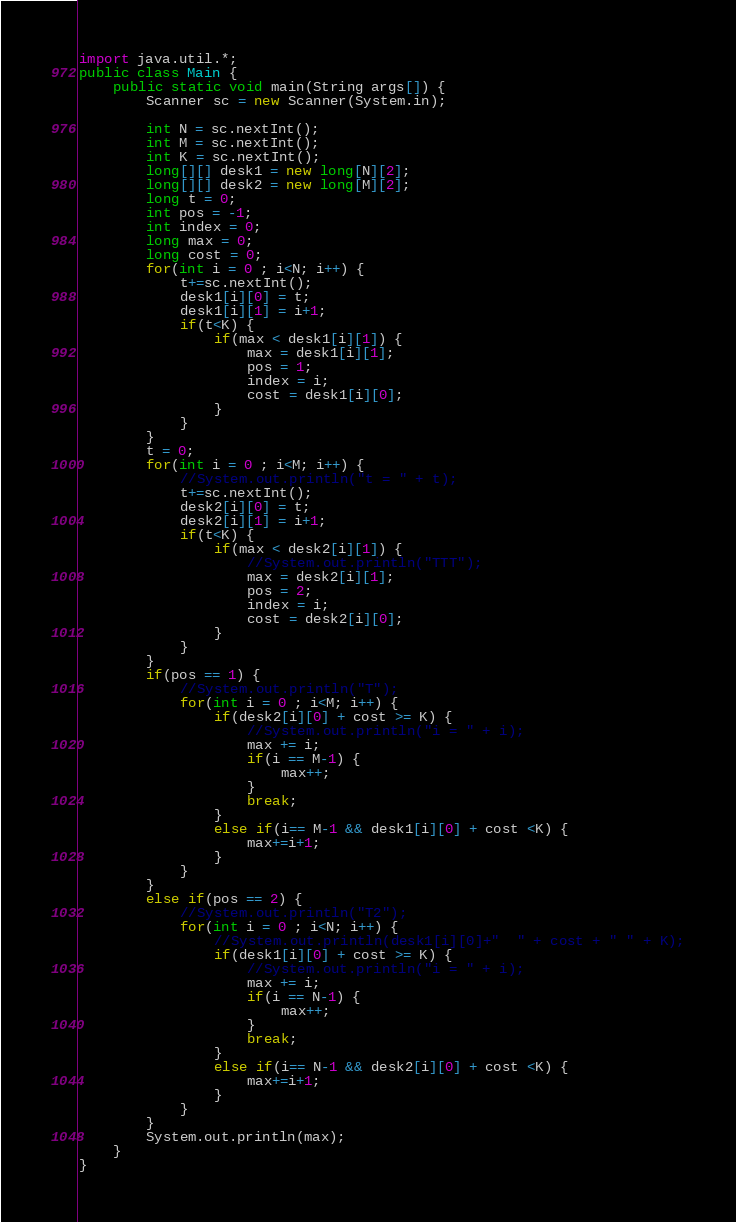Convert code to text. <code><loc_0><loc_0><loc_500><loc_500><_Java_>import java.util.*;
public class Main {
	public static void main(String args[]) {
		Scanner sc = new Scanner(System.in);
		
		int N = sc.nextInt();
		int M = sc.nextInt();
		int K = sc.nextInt();
		long[][] desk1 = new long[N][2];
		long[][] desk2 = new long[M][2];
		long t = 0;
		int pos = -1;
		int index = 0;
		long max = 0;
		long cost = 0;
		for(int i = 0 ; i<N; i++) {
			t+=sc.nextInt();
			desk1[i][0] = t;
			desk1[i][1] = i+1;
			if(t<K) {
				if(max < desk1[i][1]) {
					max = desk1[i][1];
					pos = 1;
					index = i;
					cost = desk1[i][0];
				}
			}
		}
		t = 0;
		for(int i = 0 ; i<M; i++) {
			//System.out.println("t = " + t);
			t+=sc.nextInt();
			desk2[i][0] = t;
			desk2[i][1] = i+1;
			if(t<K) {
				if(max < desk2[i][1]) {
					//System.out.println("TTT");
					max = desk2[i][1];
					pos = 2;
					index = i;
					cost = desk2[i][0];
				}
			}
		}
		if(pos == 1) {
			//System.out.println("T");
			for(int i = 0 ; i<M; i++) {
				if(desk2[i][0] + cost >= K) {
					//System.out.println("i = " + i);
					max += i;
					if(i == M-1) {
						max++;
					}
					break;
				}
				else if(i== M-1 && desk1[i][0] + cost <K) {
					max+=i+1;
				}
			}
		}
		else if(pos == 2) {
			//System.out.println("T2");
			for(int i = 0 ; i<N; i++) {
				//System.out.println(desk1[i][0]+"  " + cost + " " + K);
				if(desk1[i][0] + cost >= K) {
					//System.out.println("i = " + i);
					max += i;
					if(i == N-1) {
						max++;
					}
					break;
				}
				else if(i== N-1 && desk2[i][0] + cost <K) {
					max+=i+1;
				}
			}
		}
		System.out.println(max);
	}
}
</code> 